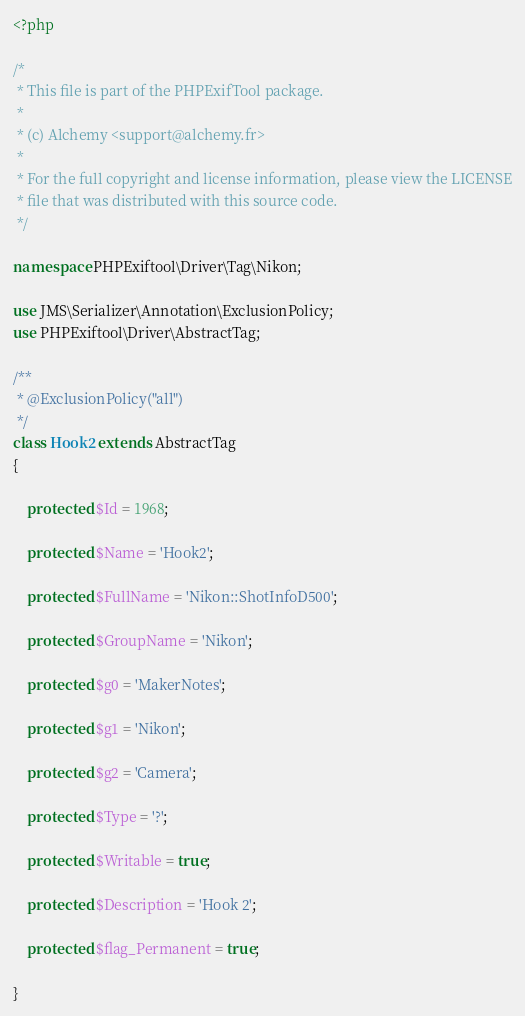<code> <loc_0><loc_0><loc_500><loc_500><_PHP_><?php

/*
 * This file is part of the PHPExifTool package.
 *
 * (c) Alchemy <support@alchemy.fr>
 *
 * For the full copyright and license information, please view the LICENSE
 * file that was distributed with this source code.
 */

namespace PHPExiftool\Driver\Tag\Nikon;

use JMS\Serializer\Annotation\ExclusionPolicy;
use PHPExiftool\Driver\AbstractTag;

/**
 * @ExclusionPolicy("all")
 */
class Hook2 extends AbstractTag
{

    protected $Id = 1968;

    protected $Name = 'Hook2';

    protected $FullName = 'Nikon::ShotInfoD500';

    protected $GroupName = 'Nikon';

    protected $g0 = 'MakerNotes';

    protected $g1 = 'Nikon';

    protected $g2 = 'Camera';

    protected $Type = '?';

    protected $Writable = true;

    protected $Description = 'Hook 2';

    protected $flag_Permanent = true;

}
</code> 